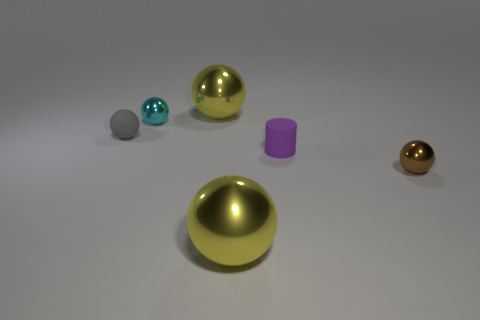How many yellow balls must be subtracted to get 1 yellow balls? 1 Subtract all brown cylinders. How many yellow spheres are left? 2 Add 4 gray metal cylinders. How many objects exist? 10 Subtract all yellow spheres. How many spheres are left? 3 Subtract all brown balls. How many balls are left? 4 Subtract all cylinders. How many objects are left? 5 Subtract all blue balls. Subtract all purple cubes. How many balls are left? 5 Add 4 small purple rubber cylinders. How many small purple rubber cylinders are left? 5 Add 1 big yellow things. How many big yellow things exist? 3 Subtract 2 yellow balls. How many objects are left? 4 